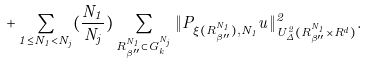Convert formula to latex. <formula><loc_0><loc_0><loc_500><loc_500>+ \sum _ { 1 \leq N _ { 1 } < N _ { j } } ( \frac { N _ { 1 } } { N _ { j } } ) \sum _ { R _ { \beta ^ { \prime \prime } } ^ { N _ { 1 } } \subset G _ { k } ^ { N _ { j } } } \| P _ { \xi ( R _ { \beta ^ { \prime \prime } } ^ { N _ { 1 } } ) , N _ { 1 } } u \| _ { U _ { \Delta } ^ { 2 } ( R _ { \beta ^ { \prime \prime } } ^ { N _ { 1 } } \times R ^ { d } ) } ^ { 2 } .</formula> 